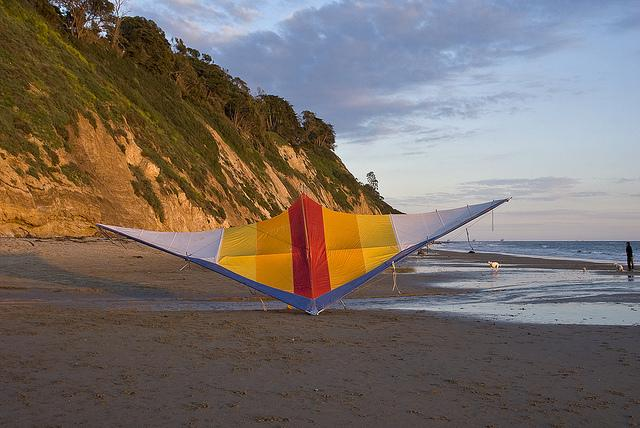What color is in the middle of the kite?

Choices:
A) red
B) blue
C) black
D) green red 